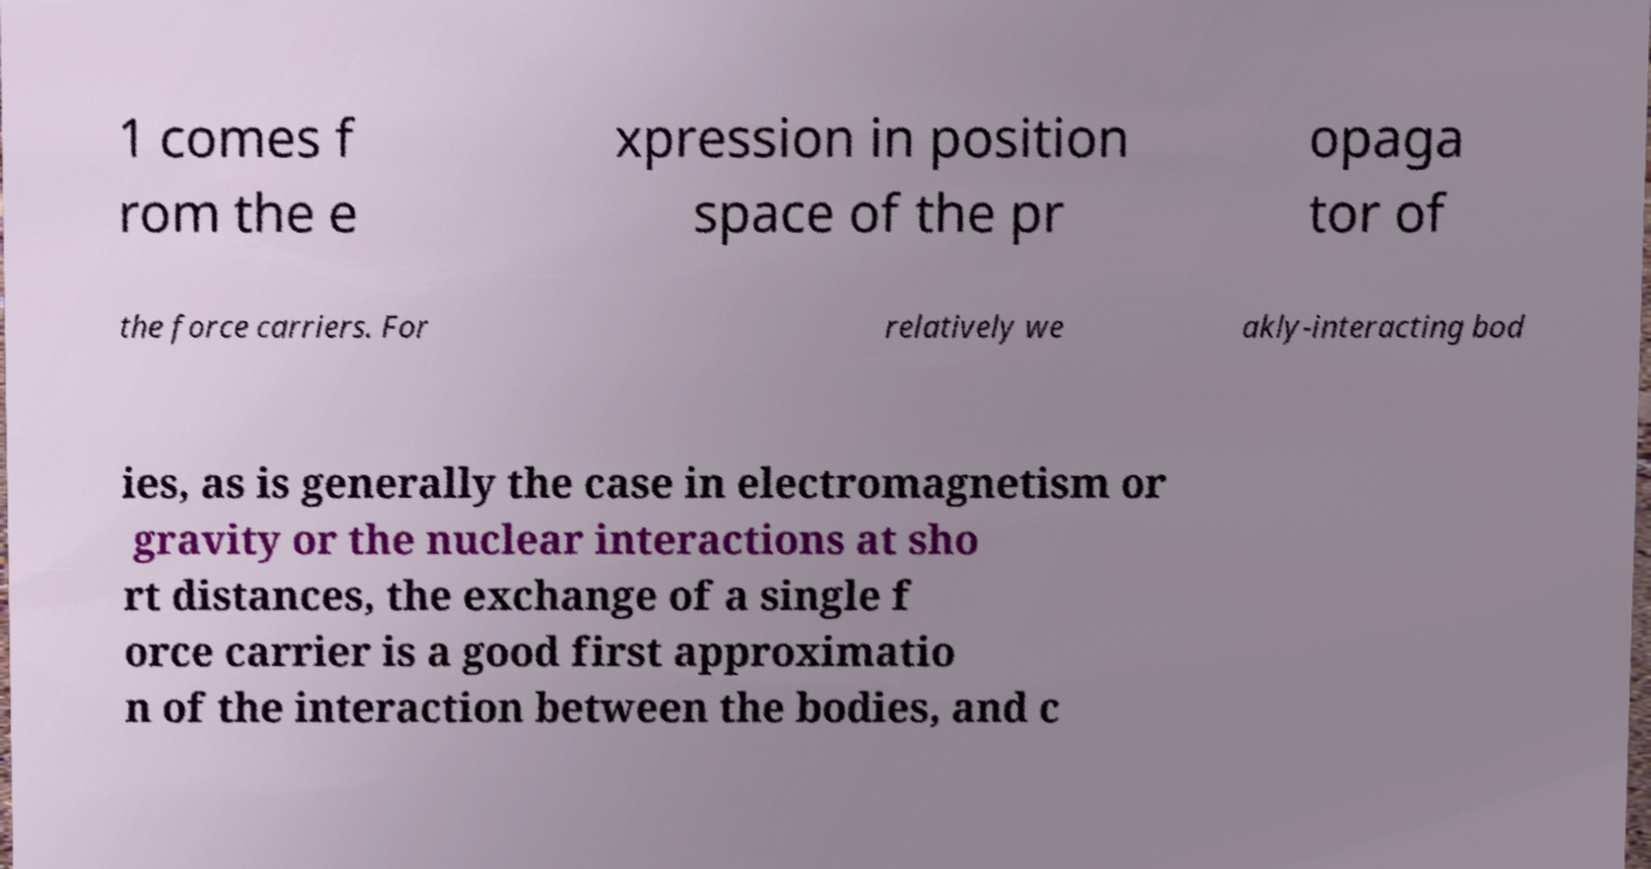I need the written content from this picture converted into text. Can you do that? 1 comes f rom the e xpression in position space of the pr opaga tor of the force carriers. For relatively we akly-interacting bod ies, as is generally the case in electromagnetism or gravity or the nuclear interactions at sho rt distances, the exchange of a single f orce carrier is a good first approximatio n of the interaction between the bodies, and c 